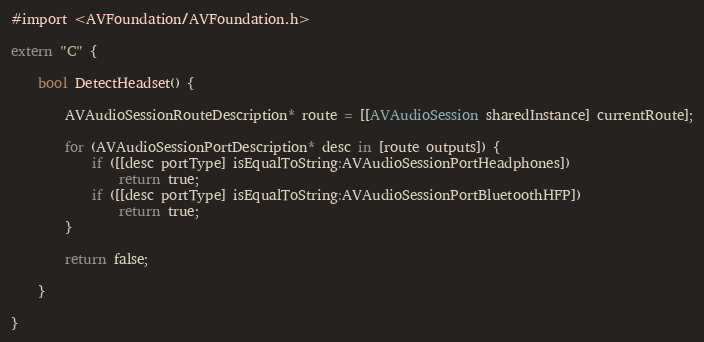<code> <loc_0><loc_0><loc_500><loc_500><_ObjectiveC_>#import <AVFoundation/AVFoundation.h>

extern "C" {

	bool DetectHeadset() {
		
        AVAudioSessionRouteDescription* route = [[AVAudioSession sharedInstance] currentRoute];
        
        for (AVAudioSessionPortDescription* desc in [route outputs]) {
            if ([[desc portType] isEqualToString:AVAudioSessionPortHeadphones])
                return true;
            if ([[desc portType] isEqualToString:AVAudioSessionPortBluetoothHFP])
                return true;
        }
        
        return false;
        
	}
	
}
</code> 